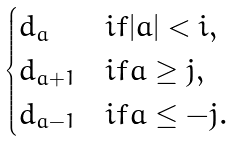Convert formula to latex. <formula><loc_0><loc_0><loc_500><loc_500>\begin{cases} d _ { a } & i f | a | < i , \\ d _ { a + 1 } & i f a \geq j , \\ d _ { a - 1 } & i f a \leq - j . \end{cases}</formula> 